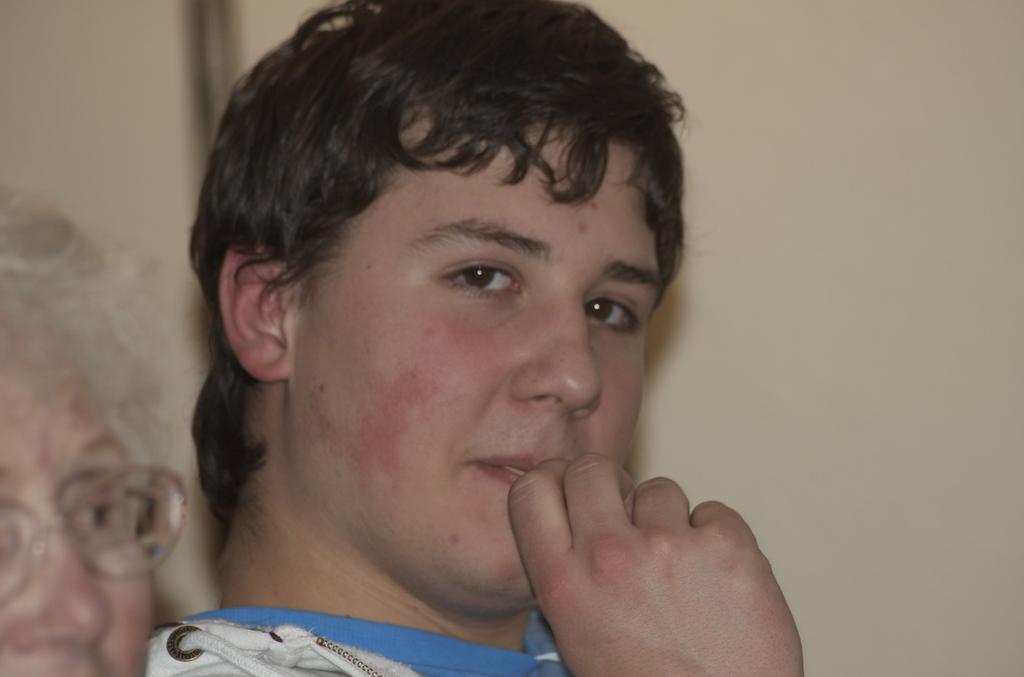Can you describe this image briefly? In this image, I can see a man. On the left side of the image, I can see another person with spectacles. In the background, there is a wall. 